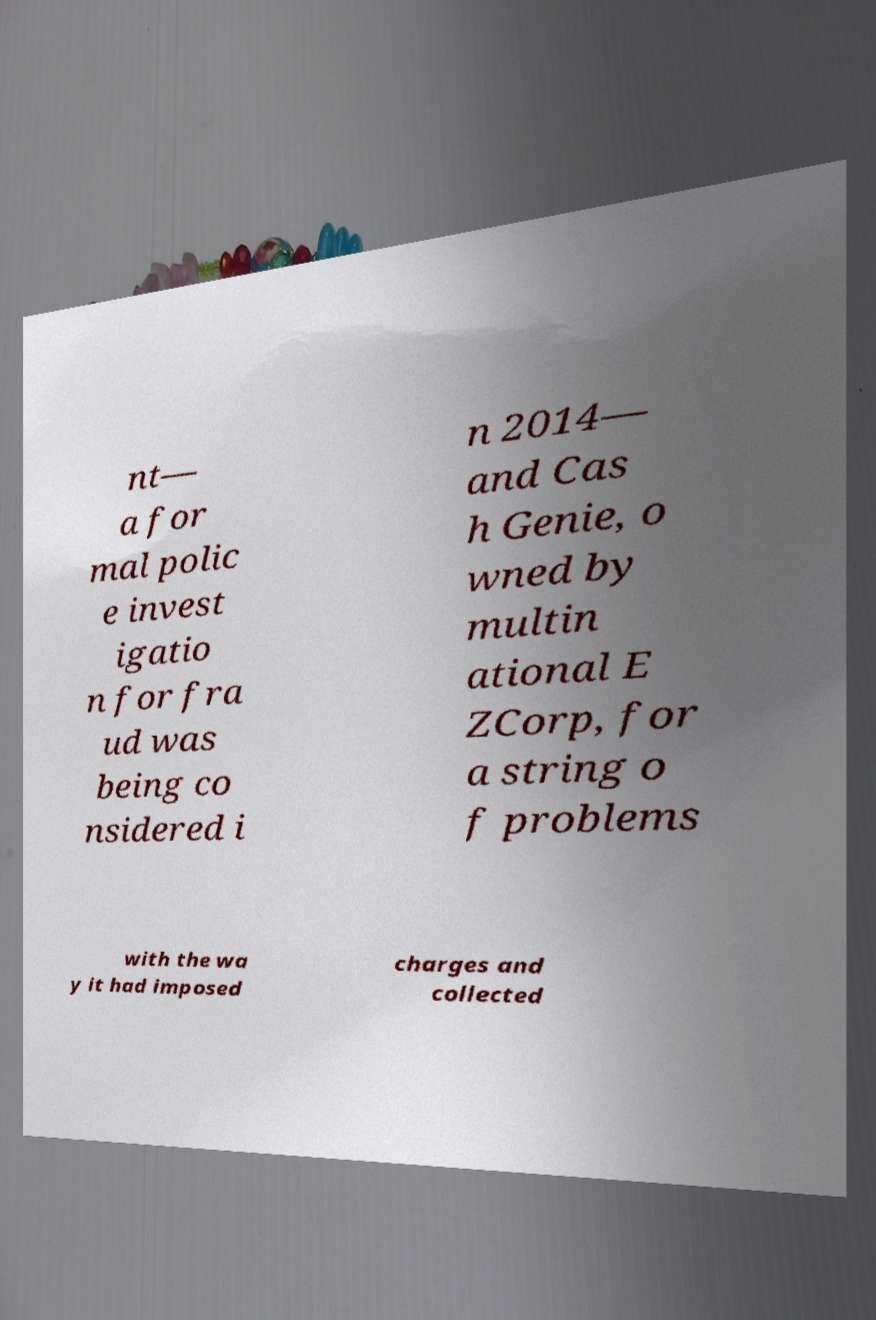Could you extract and type out the text from this image? nt— a for mal polic e invest igatio n for fra ud was being co nsidered i n 2014— and Cas h Genie, o wned by multin ational E ZCorp, for a string o f problems with the wa y it had imposed charges and collected 